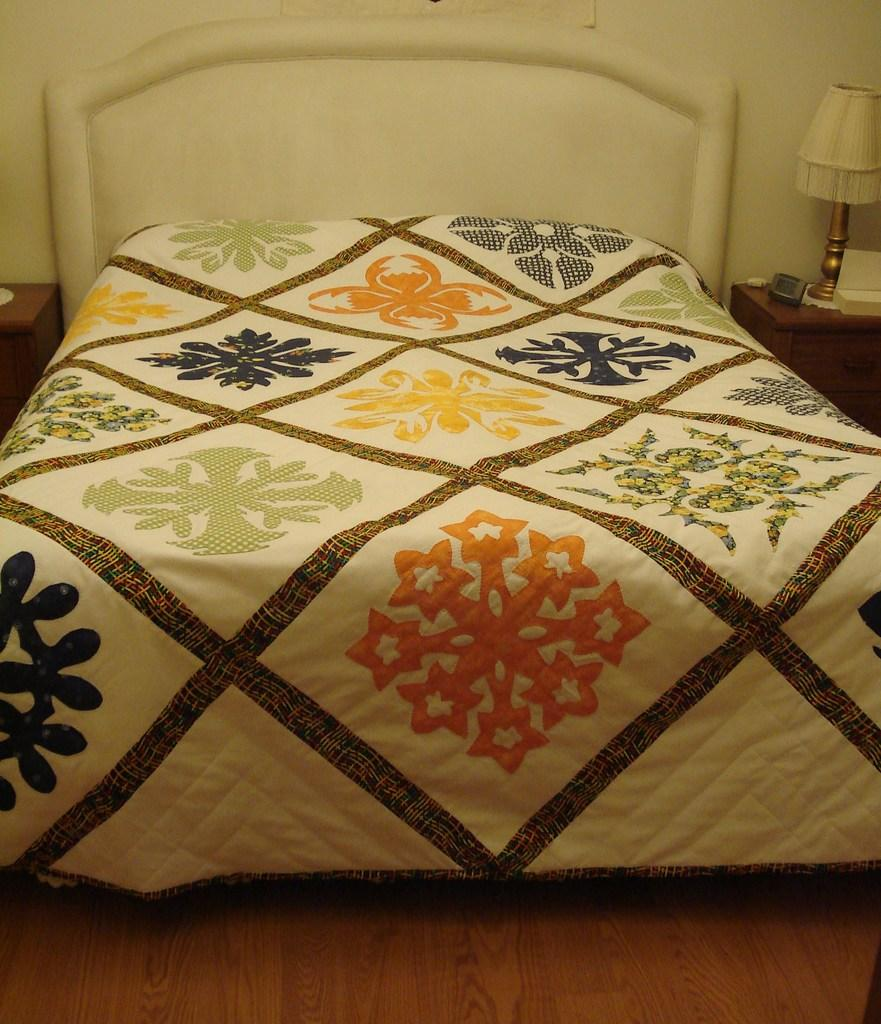What piece of furniture is present in the image? There is a bed in the image. What color is the bed? The bed is white. What type of blanket is on the bed? There is a multicolor blanket on the bed. What can be seen on a table in the background? There is a lamp on a table in the background. What color is the wall in the background? The wall in the background is white. How many sisters are sitting on the bed in the image? There are no sisters present in the image; it only shows a bed with a multicolor blanket. 